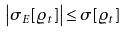Convert formula to latex. <formula><loc_0><loc_0><loc_500><loc_500>\left | \sigma _ { E } [ \varrho _ { t } ] \right | \leq \sigma [ \varrho _ { t } ] \</formula> 